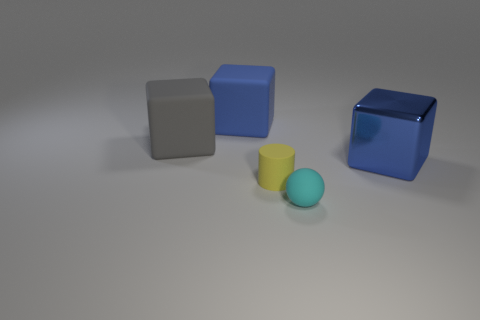Subtract all blue cubes. How many were subtracted if there are1blue cubes left? 1 Add 1 big gray things. How many objects exist? 6 Subtract all spheres. How many objects are left? 4 Subtract all large purple matte spheres. Subtract all big gray matte blocks. How many objects are left? 4 Add 2 blue matte objects. How many blue matte objects are left? 3 Add 3 large blue matte blocks. How many large blue matte blocks exist? 4 Subtract 0 brown cylinders. How many objects are left? 5 